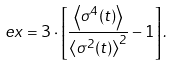Convert formula to latex. <formula><loc_0><loc_0><loc_500><loc_500>e x = 3 \cdot \left [ \frac { \left < \sigma ^ { 4 } ( t ) \right > } { \left < \sigma ^ { 2 } ( t ) \right > ^ { 2 } } - 1 \right ] .</formula> 